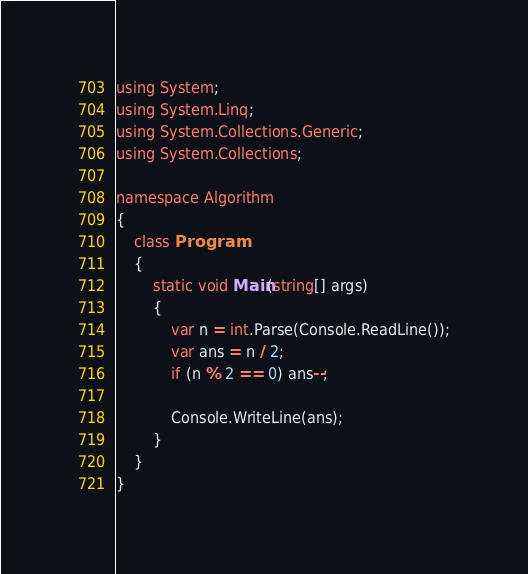<code> <loc_0><loc_0><loc_500><loc_500><_C#_>using System;
using System.Linq;
using System.Collections.Generic;
using System.Collections;

namespace Algorithm
{
    class Program
    {
        static void Main(string[] args)
        {
            var n = int.Parse(Console.ReadLine());
            var ans = n / 2;
            if (n % 2 == 0) ans--;

            Console.WriteLine(ans);
        }
    }
}
</code> 